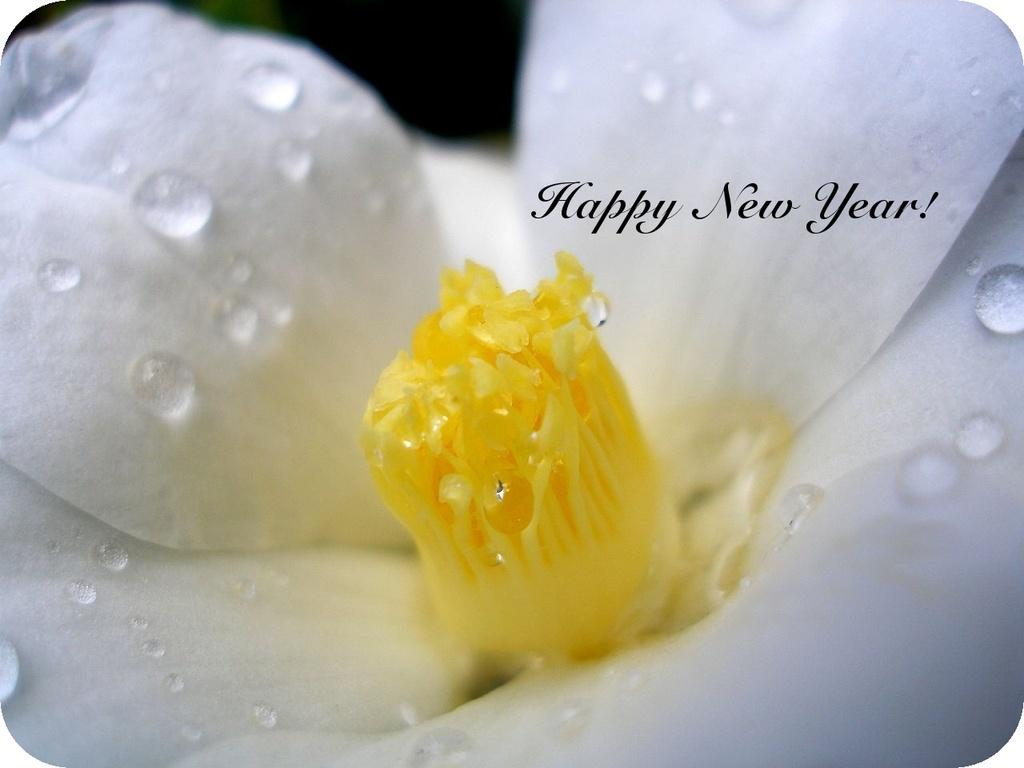What is the main subject of the image? There is a flower in the image. What type of cloth is used to make the jam in the image? There is no cloth or jam present in the image; it only features a flower. 